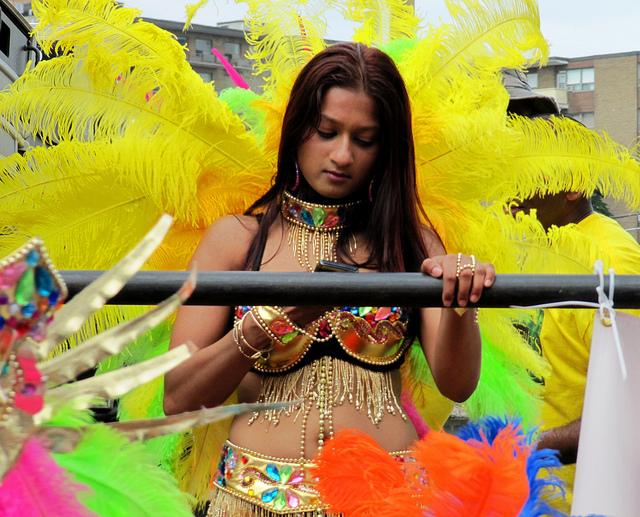Is this a colorful scene?
Keep it brief. Yes. Is the girl wearing earrings?
Short answer required. Yes. Can you see her belly button?
Concise answer only. Yes. 